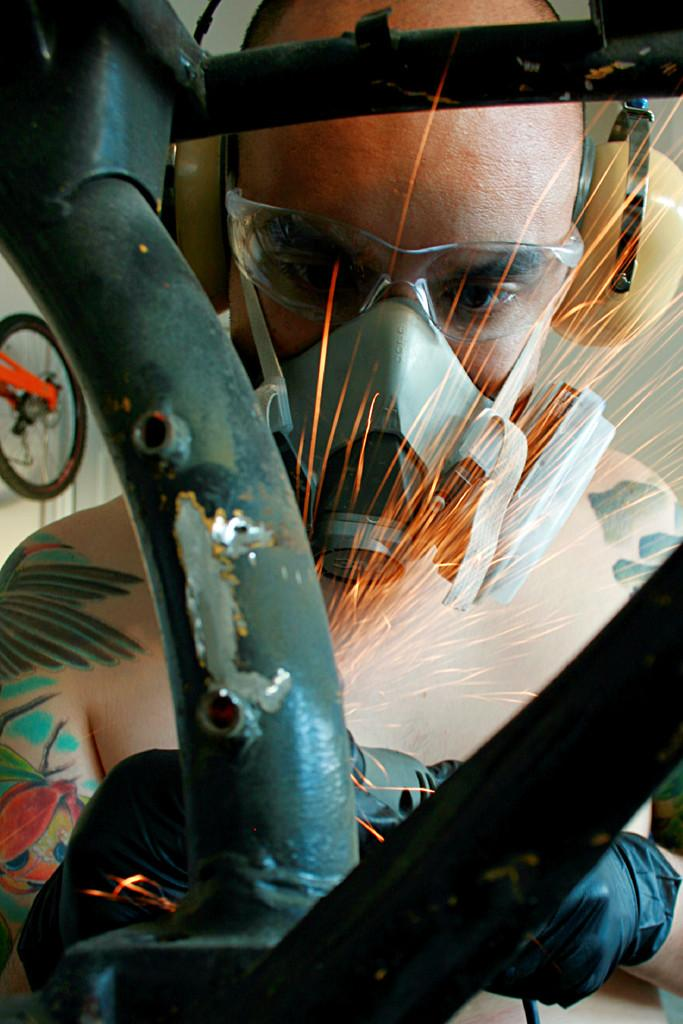Who is the main subject in the image? There is a man in the image. What is the man doing in the image? The man appears to be welding. Can you describe the man's position in the image? The man is standing. What protective gear is the man wearing in the image? The man is wearing headphones. How many brothers does the man have in the image? There is no information about the man's brothers in the image. What decision did the man make before starting to weld in the image? There is no information about any decisions made by the man in the image. 